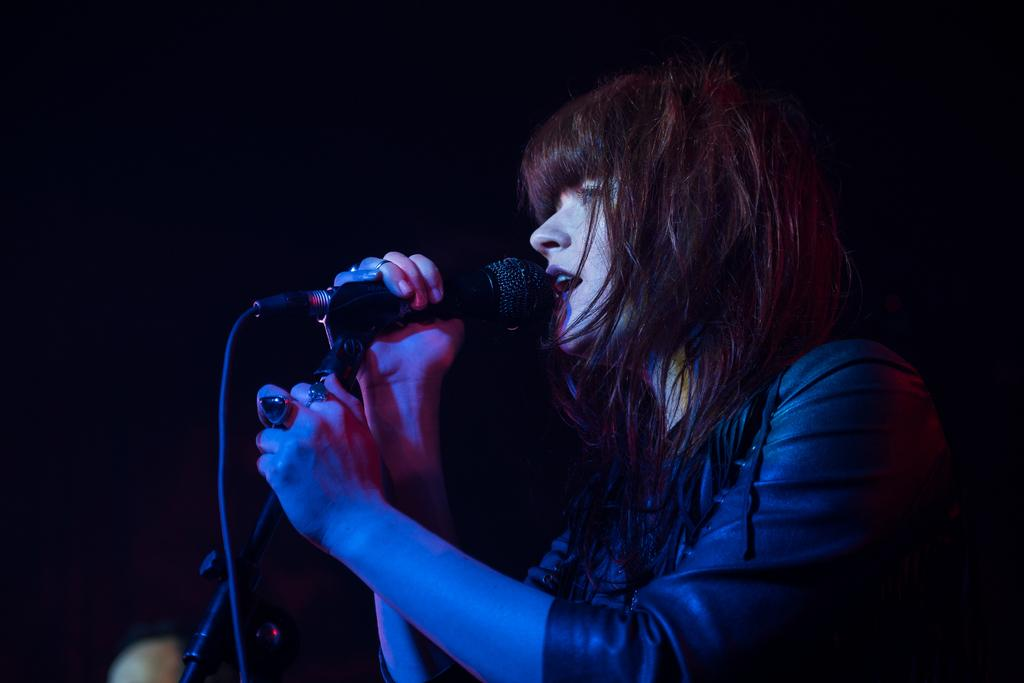Who is the main subject in the image? There is a woman in the image. What is the woman holding in her hands? The woman is holding a mic with her hands. What is the woman doing with the mic? The woman is talking. What can be observed about the background of the image? The background of the image is dark. What is the value of the fifth arithmetic operation in the image? There are no arithmetic operations or values present in the image. 